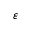Convert formula to latex. <formula><loc_0><loc_0><loc_500><loc_500>\varepsilon</formula> 